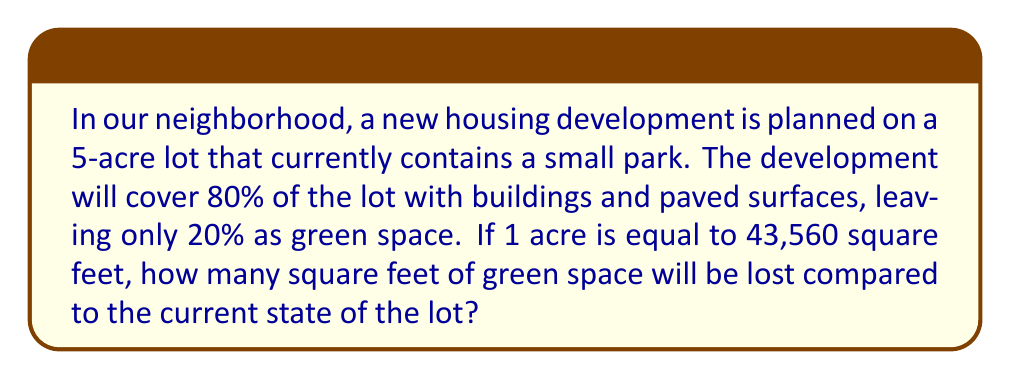Show me your answer to this math problem. To solve this problem, we'll follow these steps:

1. Calculate the total area of the lot in square feet:
   $$5 \text{ acres} \times 43,560 \frac{\text{sq ft}}{\text{acre}} = 217,800 \text{ sq ft}$$

2. Calculate the current green space (assuming the entire lot is currently green):
   $$\text{Current green space} = 217,800 \text{ sq ft}$$

3. Calculate the green space after development (20% of the total area):
   $$\text{New green space} = 20\% \times 217,800 \text{ sq ft} = 0.2 \times 217,800 \text{ sq ft} = 43,560 \text{ sq ft}$$

4. Calculate the lost green space by subtracting the new green space from the current green space:
   $$\text{Lost green space} = 217,800 \text{ sq ft} - 43,560 \text{ sq ft} = 174,240 \text{ sq ft}$$

Therefore, the neighborhood will lose 174,240 square feet of green space due to the new development.
Answer: 174,240 square feet 